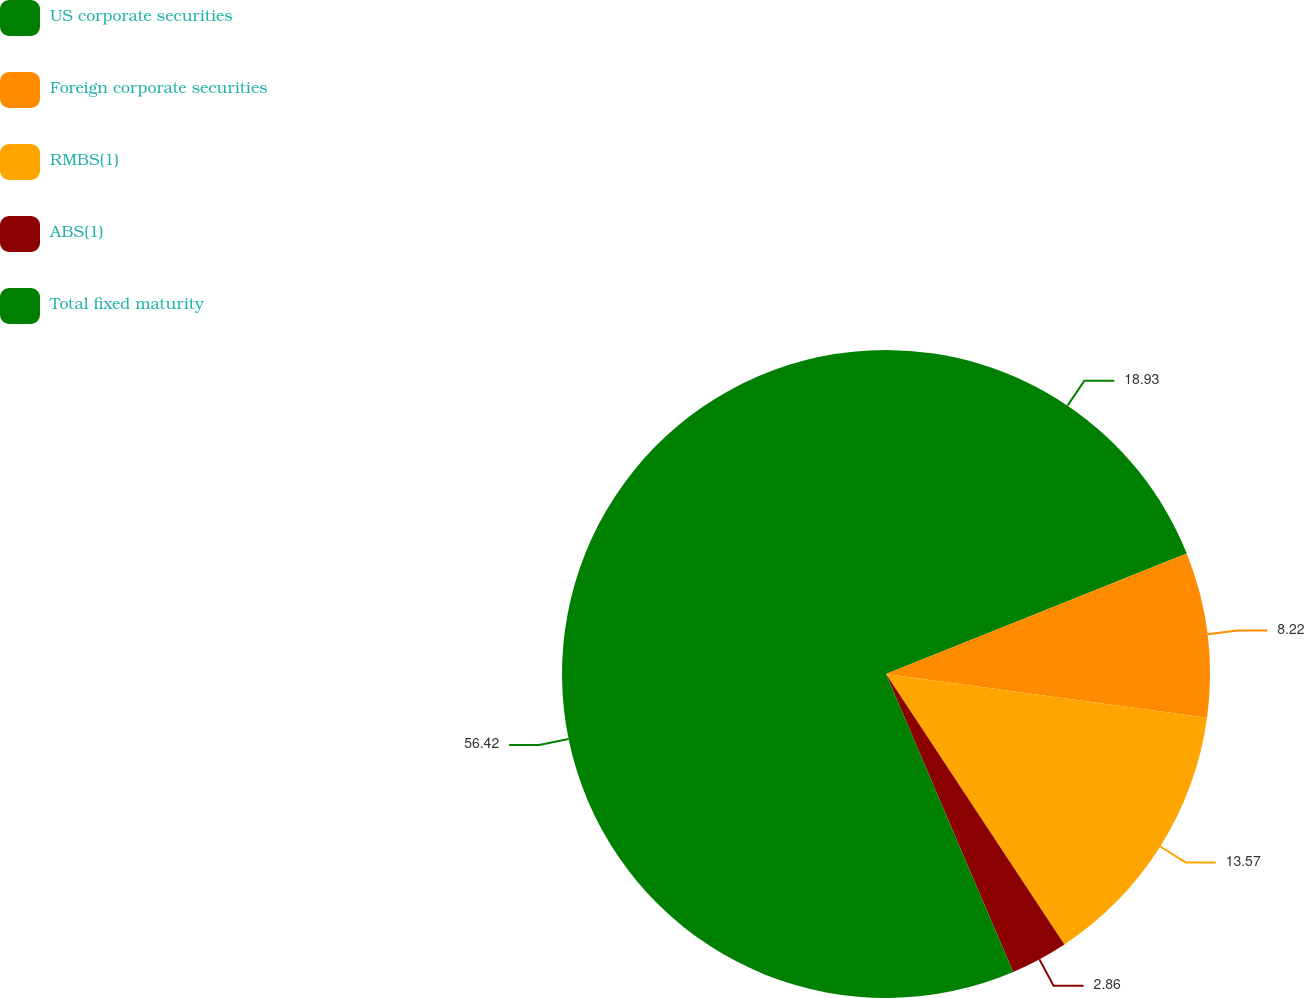<chart> <loc_0><loc_0><loc_500><loc_500><pie_chart><fcel>US corporate securities<fcel>Foreign corporate securities<fcel>RMBS(1)<fcel>ABS(1)<fcel>Total fixed maturity<nl><fcel>18.93%<fcel>8.22%<fcel>13.57%<fcel>2.86%<fcel>56.42%<nl></chart> 